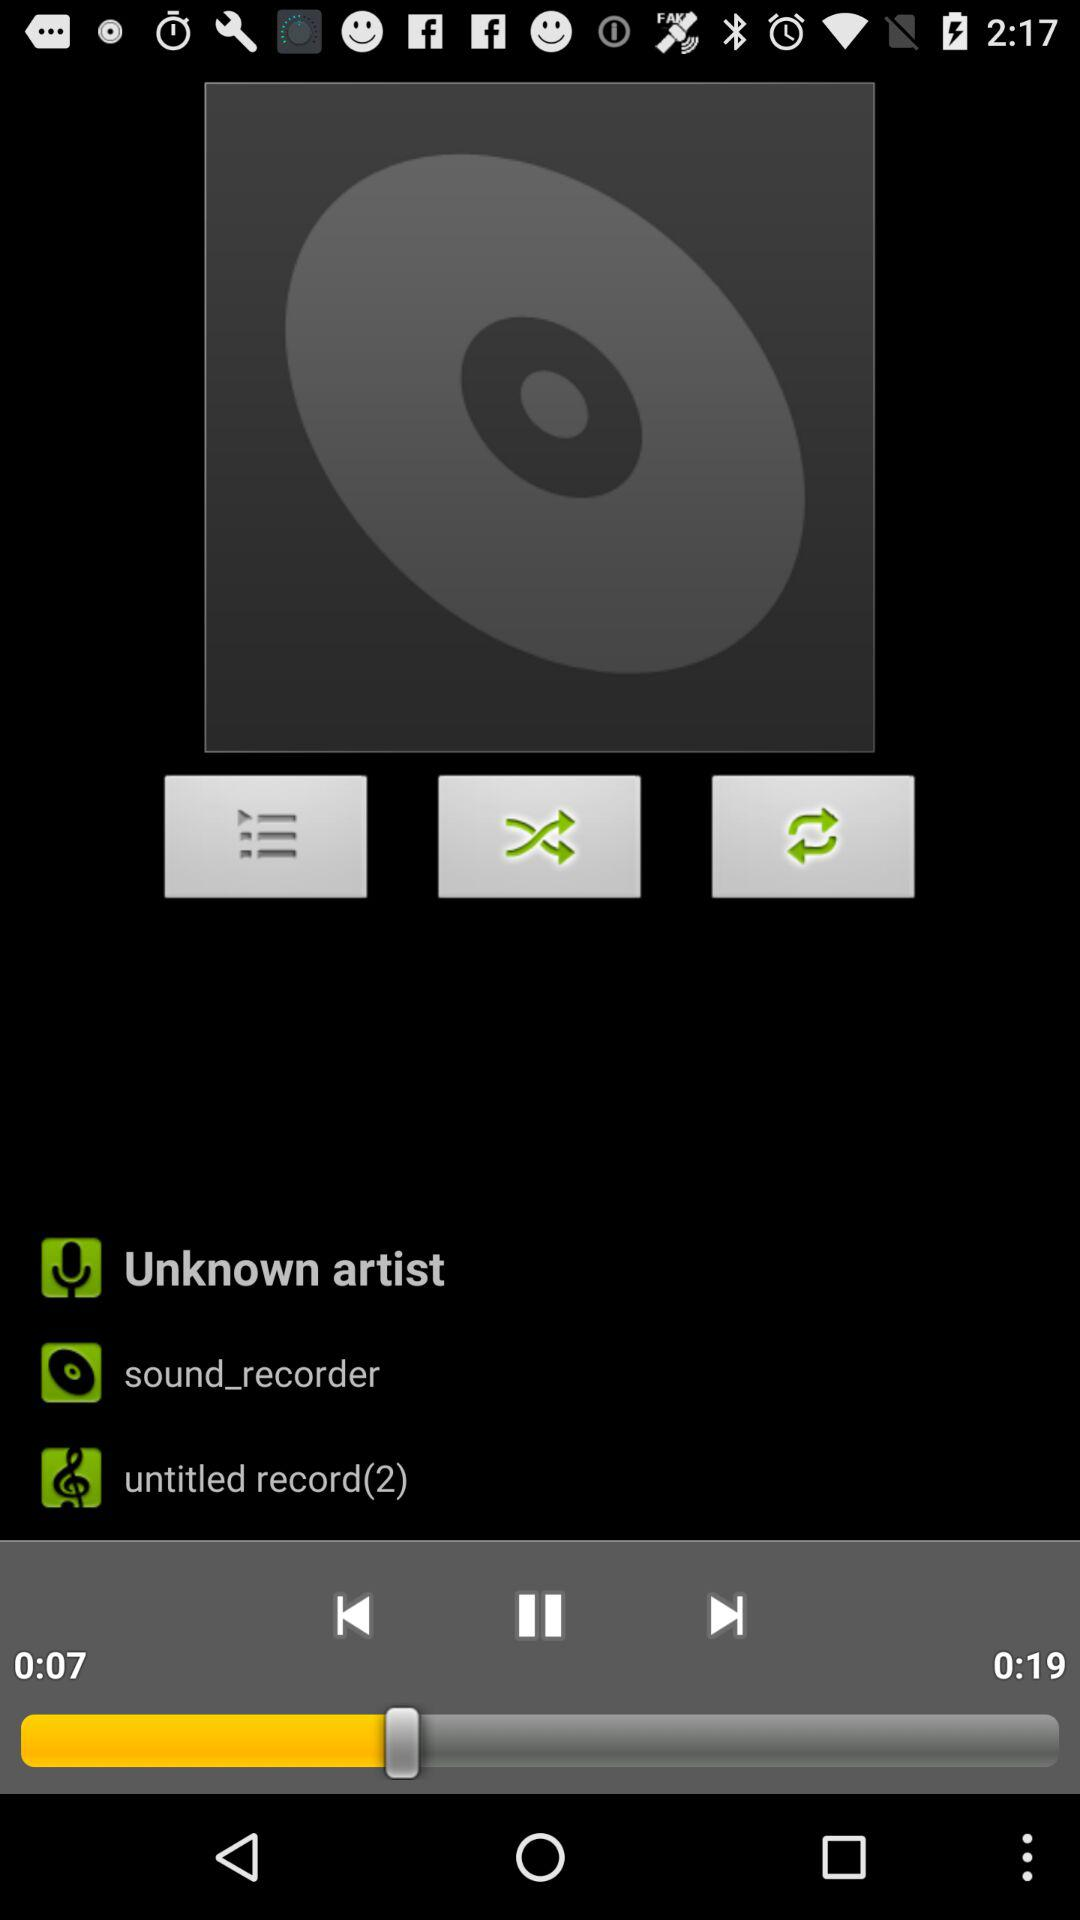How many untitled records are there?
Answer the question using a single word or phrase. 2 